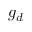Convert formula to latex. <formula><loc_0><loc_0><loc_500><loc_500>g _ { d }</formula> 